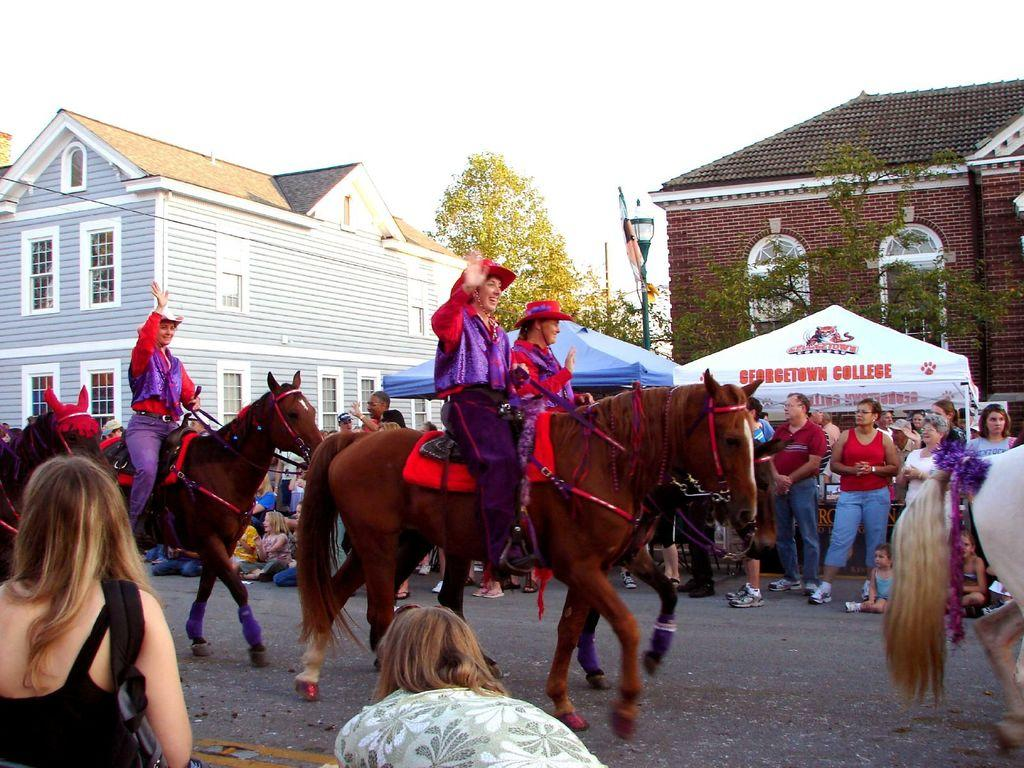What are the women doing in the image? The women are riding horses in the image. Where are the women riding their horses? The women are on a road. How are people reacting to the women riding horses? People are looking at the women from the sides of the road. What can be seen in the background of the image? There are buildings, trees, and the sky visible in the background of the image. What type of heat is being generated by the women's aunt in the image? There is no mention of an aunt or any heat generation in the image. 